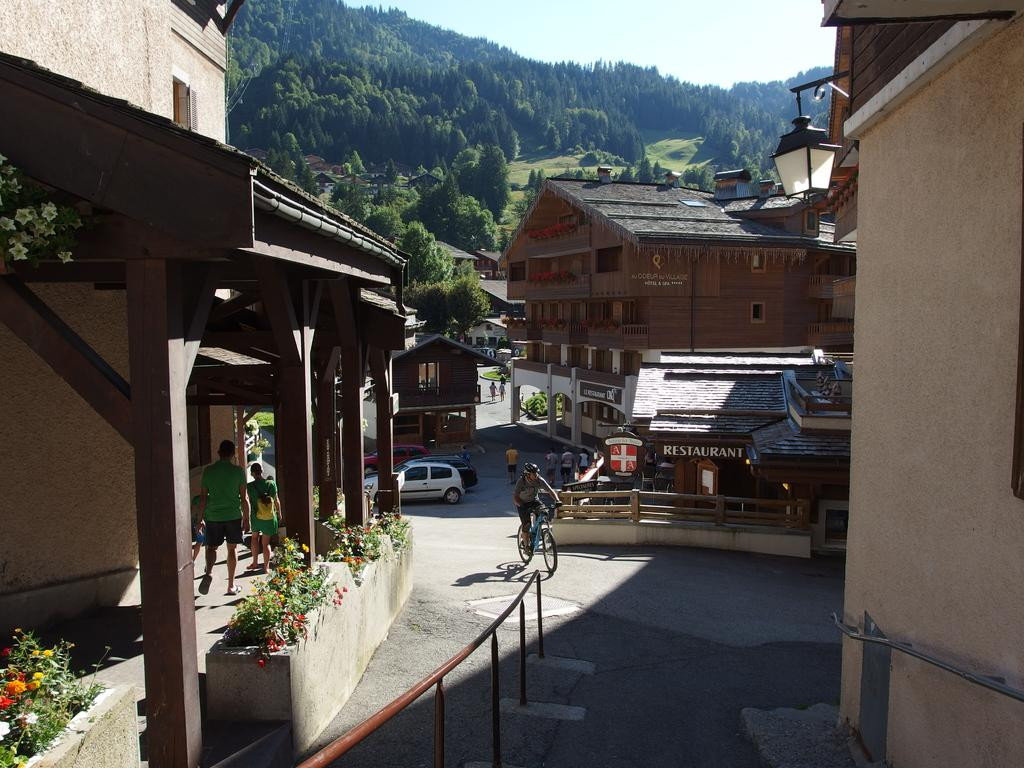<image>
Share a concise interpretation of the image provided. the word restaurant is on the brown house 